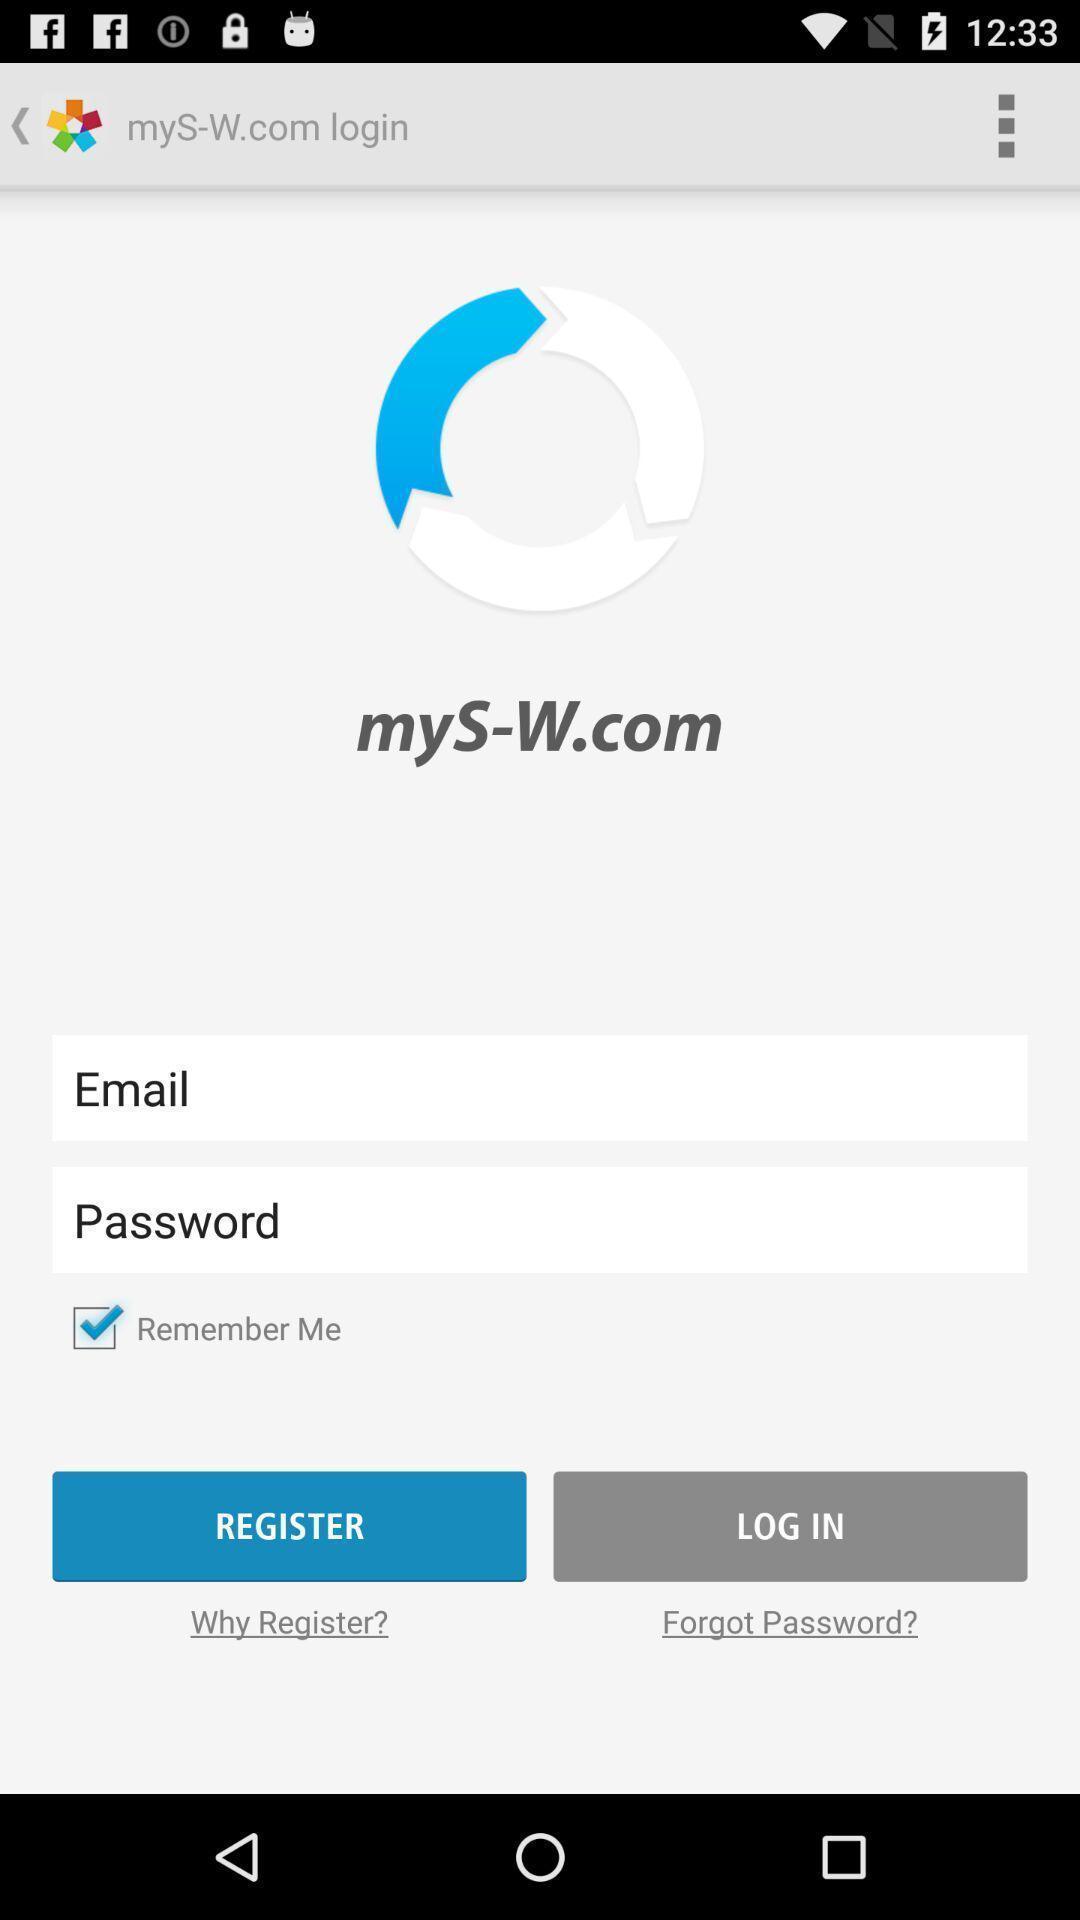Tell me what you see in this picture. Register page of the app. 